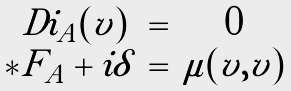<formula> <loc_0><loc_0><loc_500><loc_500>\begin{array} { c c c } \ D i _ { A } ( v ) & = & 0 \\ * F _ { A } + i \delta & = & \mu ( v , v ) \end{array}</formula> 